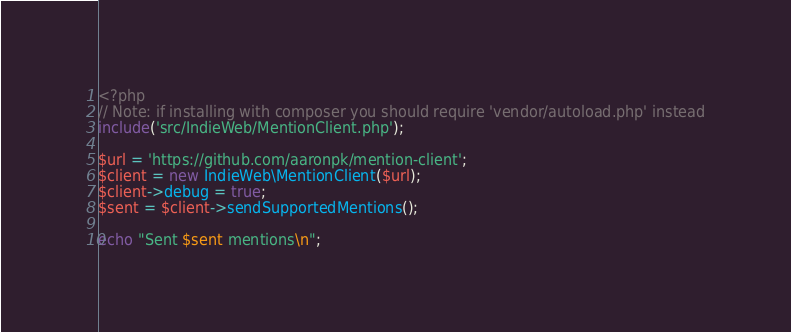<code> <loc_0><loc_0><loc_500><loc_500><_PHP_><?php
// Note: if installing with composer you should require 'vendor/autoload.php' instead
include('src/IndieWeb/MentionClient.php');

$url = 'https://github.com/aaronpk/mention-client';
$client = new IndieWeb\MentionClient($url);
$client->debug = true;
$sent = $client->sendSupportedMentions();

echo "Sent $sent mentions\n";
</code> 